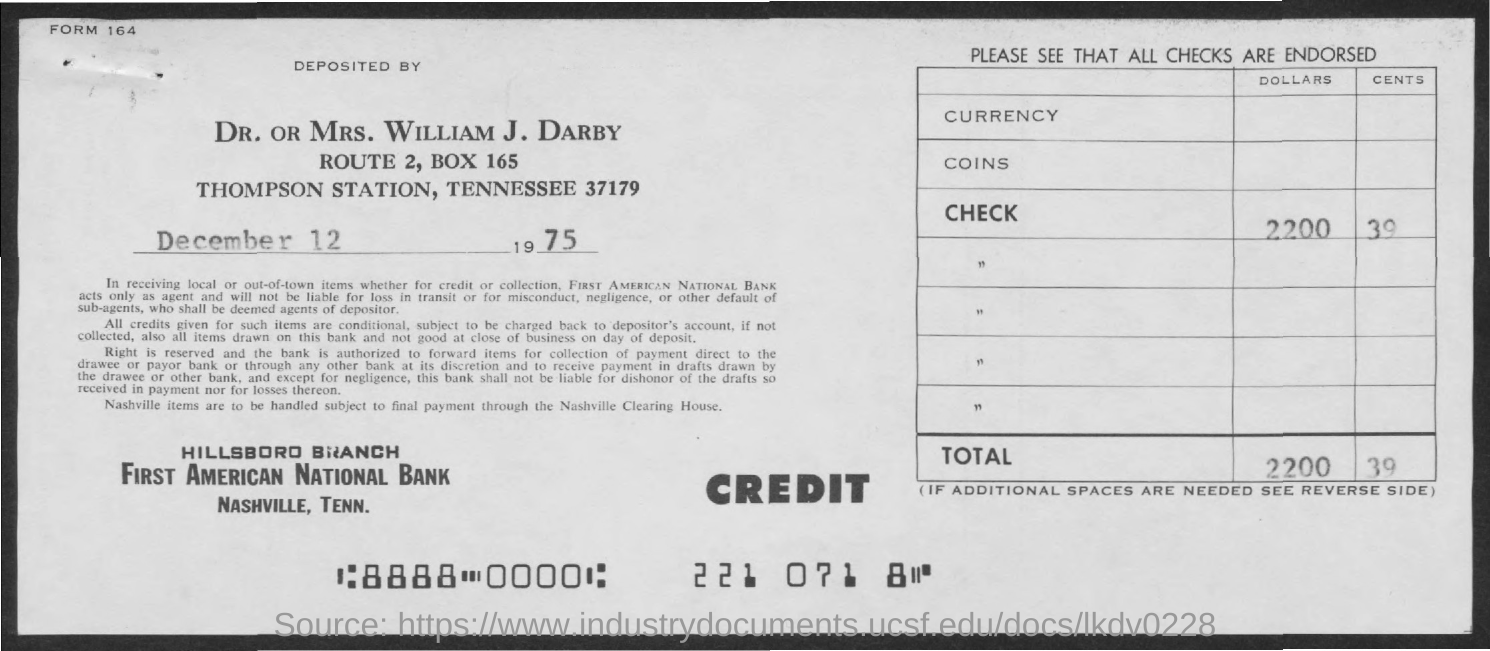Highlight a few significant elements in this photo. What is box number 165? The date mentioned in the document is December 12, 1975. 